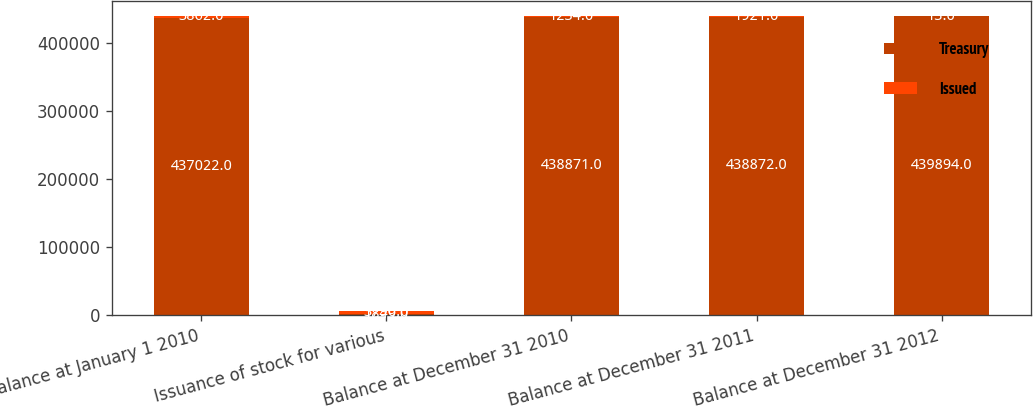Convert chart to OTSL. <chart><loc_0><loc_0><loc_500><loc_500><stacked_bar_chart><ecel><fcel>Balance at January 1 2010<fcel>Issuance of stock for various<fcel>Balance at December 31 2010<fcel>Balance at December 31 2011<fcel>Balance at December 31 2012<nl><fcel>Treasury<fcel>437022<fcel>1849<fcel>438871<fcel>438872<fcel>439894<nl><fcel>Issued<fcel>3862<fcel>3796<fcel>1234<fcel>1921<fcel>13<nl></chart> 